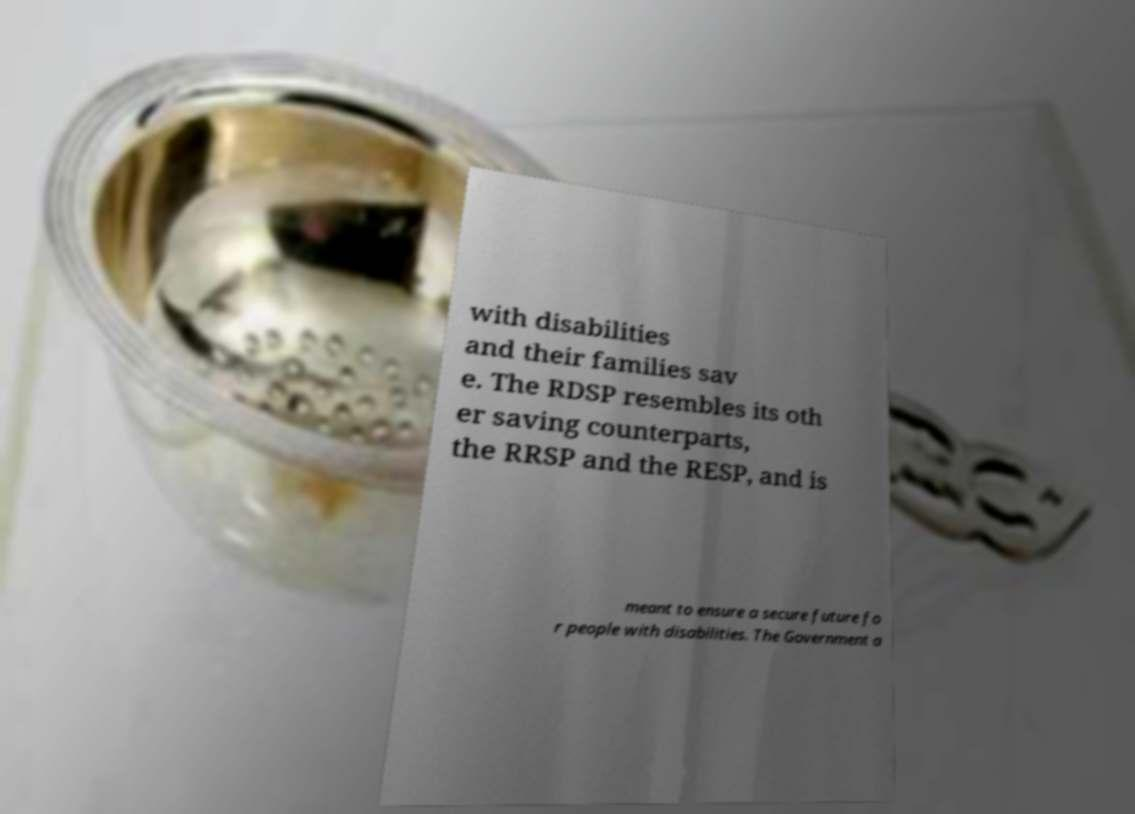Can you read and provide the text displayed in the image?This photo seems to have some interesting text. Can you extract and type it out for me? with disabilities and their families sav e. The RDSP resembles its oth er saving counterparts, the RRSP and the RESP, and is meant to ensure a secure future fo r people with disabilities. The Government a 